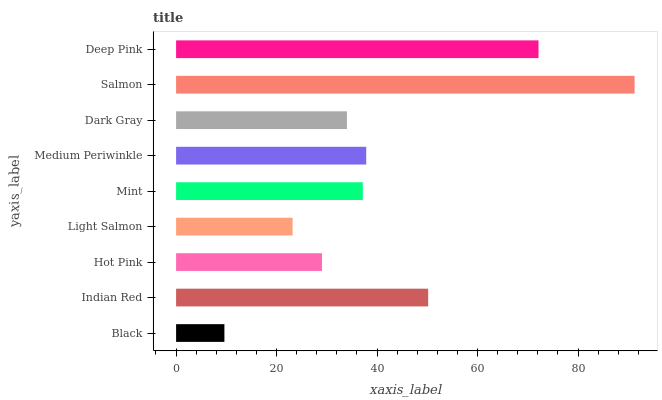Is Black the minimum?
Answer yes or no. Yes. Is Salmon the maximum?
Answer yes or no. Yes. Is Indian Red the minimum?
Answer yes or no. No. Is Indian Red the maximum?
Answer yes or no. No. Is Indian Red greater than Black?
Answer yes or no. Yes. Is Black less than Indian Red?
Answer yes or no. Yes. Is Black greater than Indian Red?
Answer yes or no. No. Is Indian Red less than Black?
Answer yes or no. No. Is Mint the high median?
Answer yes or no. Yes. Is Mint the low median?
Answer yes or no. Yes. Is Indian Red the high median?
Answer yes or no. No. Is Dark Gray the low median?
Answer yes or no. No. 